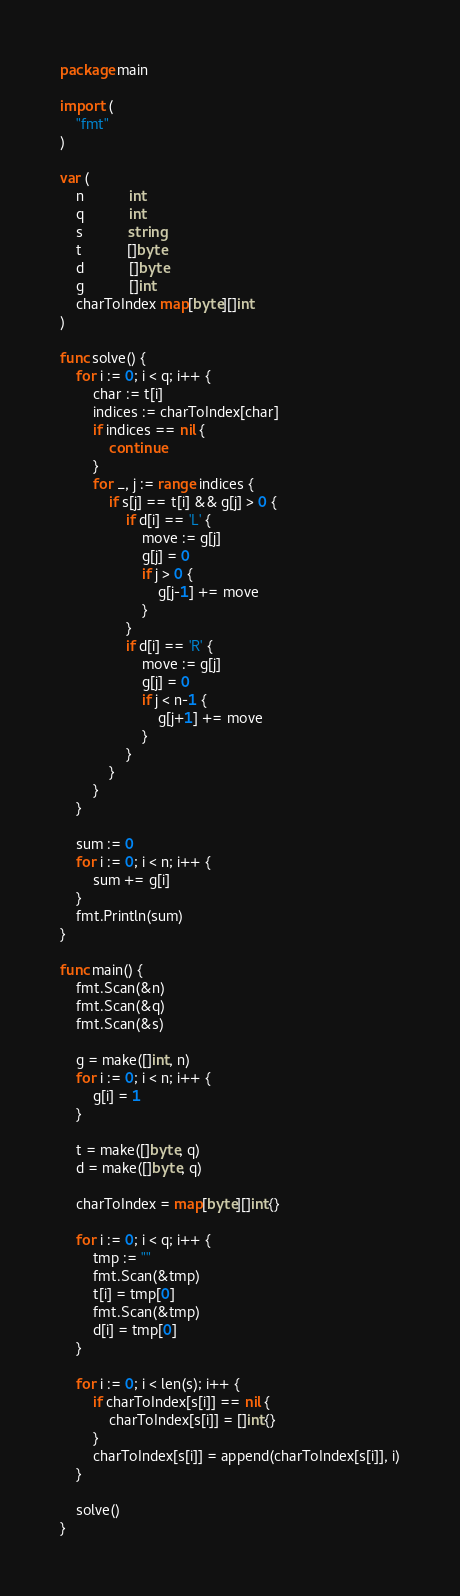<code> <loc_0><loc_0><loc_500><loc_500><_Go_>package main

import (
	"fmt"
)

var (
	n           int
	q           int
	s           string
	t           []byte
	d           []byte
	g           []int
	charToIndex map[byte][]int
)

func solve() {
	for i := 0; i < q; i++ {
		char := t[i]
		indices := charToIndex[char]
		if indices == nil {
			continue
		}
		for _, j := range indices {
			if s[j] == t[i] && g[j] > 0 {
				if d[i] == 'L' {
					move := g[j]
					g[j] = 0
					if j > 0 {
						g[j-1] += move
					}
				}
				if d[i] == 'R' {
					move := g[j]
					g[j] = 0
					if j < n-1 {
						g[j+1] += move
					}
				}
			}
		}
	}

	sum := 0
	for i := 0; i < n; i++ {
		sum += g[i]
	}
	fmt.Println(sum)
}

func main() {
	fmt.Scan(&n)
	fmt.Scan(&q)
	fmt.Scan(&s)

	g = make([]int, n)
	for i := 0; i < n; i++ {
		g[i] = 1
	}

	t = make([]byte, q)
	d = make([]byte, q)

	charToIndex = map[byte][]int{}

	for i := 0; i < q; i++ {
		tmp := ""
		fmt.Scan(&tmp)
		t[i] = tmp[0]
		fmt.Scan(&tmp)
		d[i] = tmp[0]
	}

	for i := 0; i < len(s); i++ {
		if charToIndex[s[i]] == nil {
			charToIndex[s[i]] = []int{}
		}
		charToIndex[s[i]] = append(charToIndex[s[i]], i)
	}

	solve()
}
</code> 